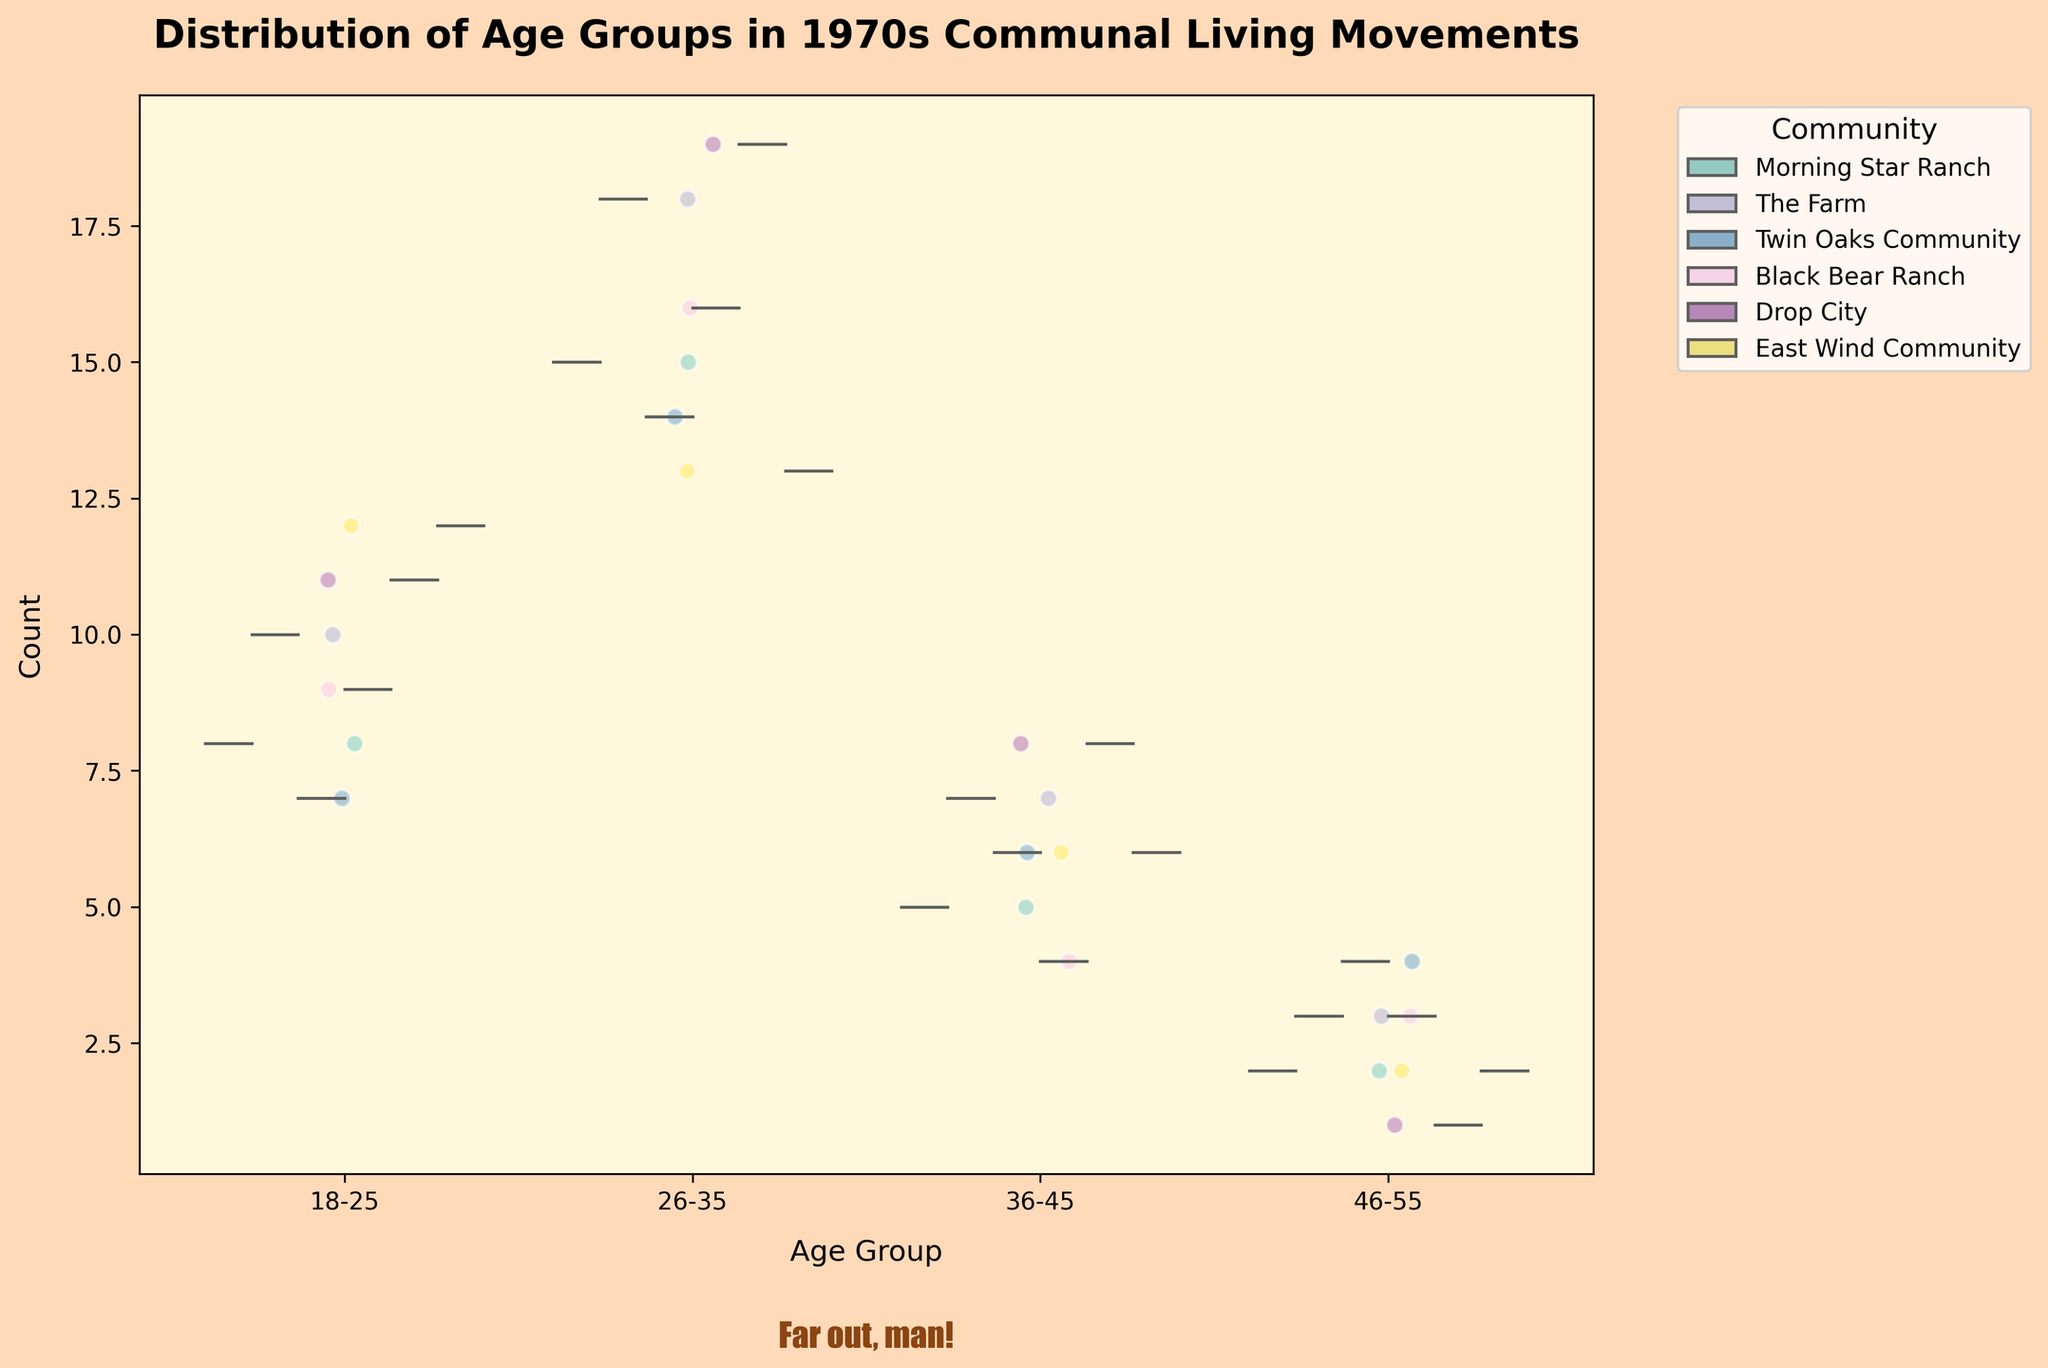what is the title of the chart? The title of the chart is located at the top, directly above the visual elements of the chart. It usually summarizes the main topic or point of the chart succinctly.
Answer: Distribution of Age Groups in 1970s Communal Living Movements which age group has the highest count in Drop City? By observing the vertical positions of the jittered points within the Drop City community's violin plots, the age group with the highest average count can be identified.
Answer: 26-35 how many communities have an age group of 36-45 with a count above 5? To answer this, one needs to look at the amount and height of the jittered points within the 36-45 age group across all communities, and count how many communities have their points above the value 5.
Answer: 5 communities what community has the smallest count in the 26-35 age group? One can determine this by checking the lowest point of the jittered points in the violin plot corresponding to the 26-35 age group for each community and identifying which is the smallest.
Answer: East Wind Community what is the count difference between age group 18-25 and 26-35 in Morning Star Ranch? The count for the 18-25 age group and the count for the 26-35 age group in Morning Star Ranch are noted. The difference is the count of the 26-35 age group minus the count of the 18-25 age group.
Answer: 7 which community has the highest count in the age group 46-55? By observing all communities' violin plots within the 46-55 age group and identifying the highest count shown by the jittered points.
Answer: Twin Oaks Community is the count evenly distributed among age groups in any community? An even distribution would show violin plots of similar shape and size across all age groups for a single community. The presence of significantly varied heights indicates otherwise.
Answer: No which age group in The Farm has the most jittered points? The number of jittered points for each age group within The Farm community is counted to determine which has the most.
Answer: 26-35 compare the median counts for the age groups 26-35 and 36-45 across all communities. Which is higher? To determine the median counts, observe the central tendency (center line) within the violin plots for each age group across all communities. Compare these medians to see which age group has the higher central value.
Answer: 26-35 what is the overall trend of age group distribution in communal living movements of the 1970s? By scanning the height and density of each age group's violin plot across all communities, one can determine that certain age groups dominate in population across the different communities—a visible overall trend.
Answer: Younger age groups (18-35) have higher counts 